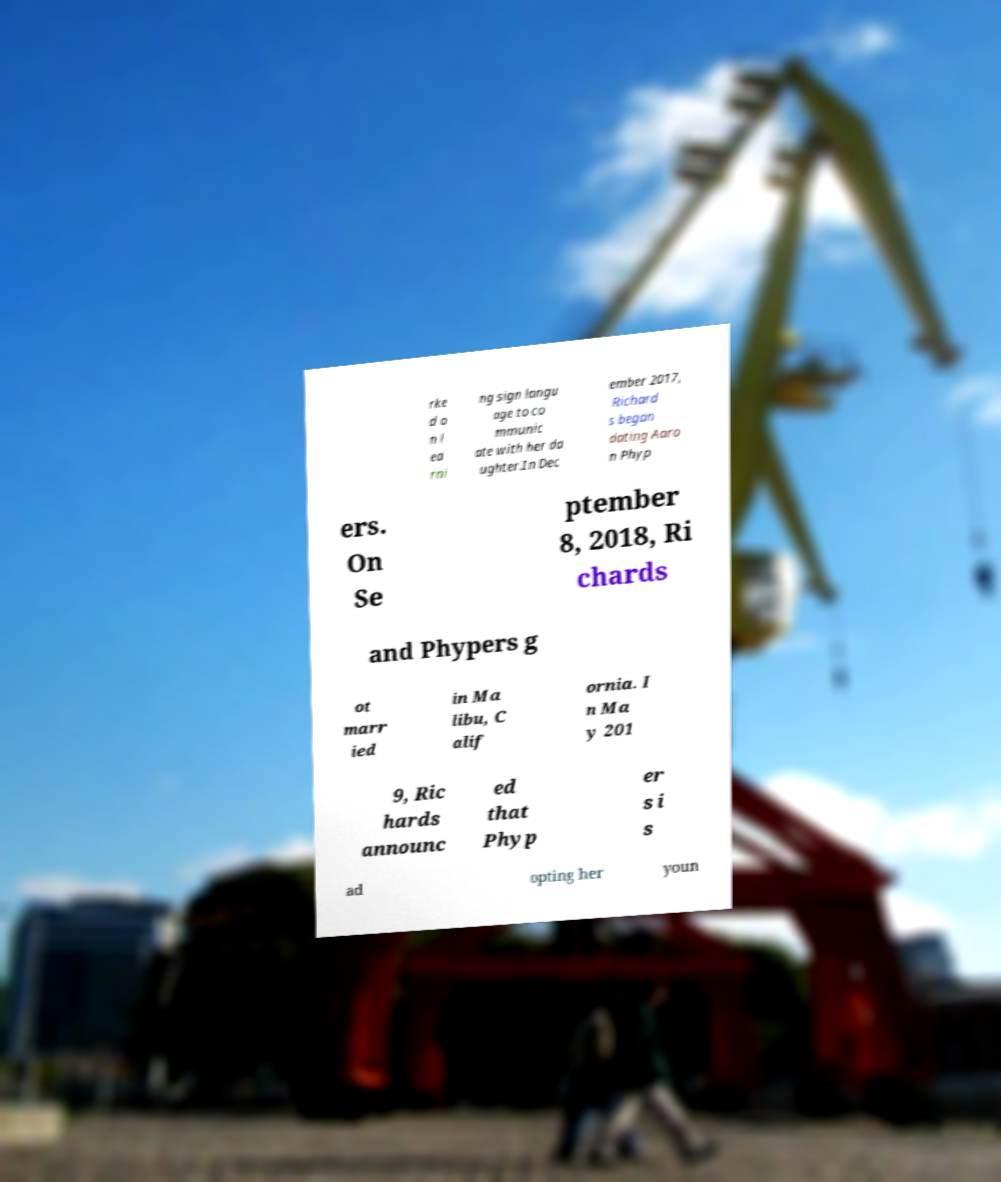Please read and relay the text visible in this image. What does it say? rke d o n l ea rni ng sign langu age to co mmunic ate with her da ughter.In Dec ember 2017, Richard s began dating Aaro n Phyp ers. On Se ptember 8, 2018, Ri chards and Phypers g ot marr ied in Ma libu, C alif ornia. I n Ma y 201 9, Ric hards announc ed that Phyp er s i s ad opting her youn 